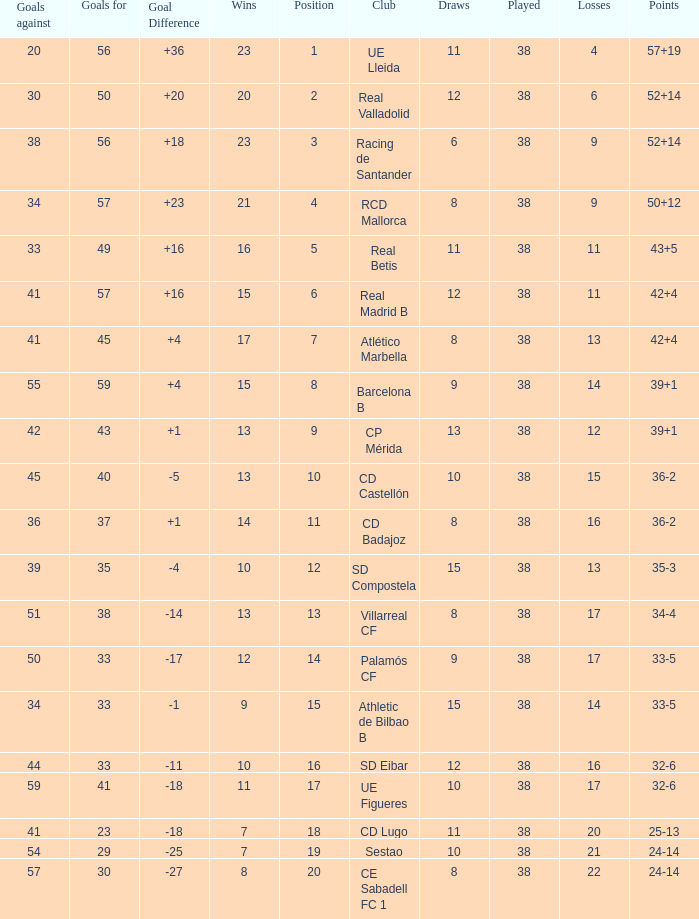What is the highest number of wins with a goal difference less than 4 at the Villarreal CF and more than 38 played? None. 